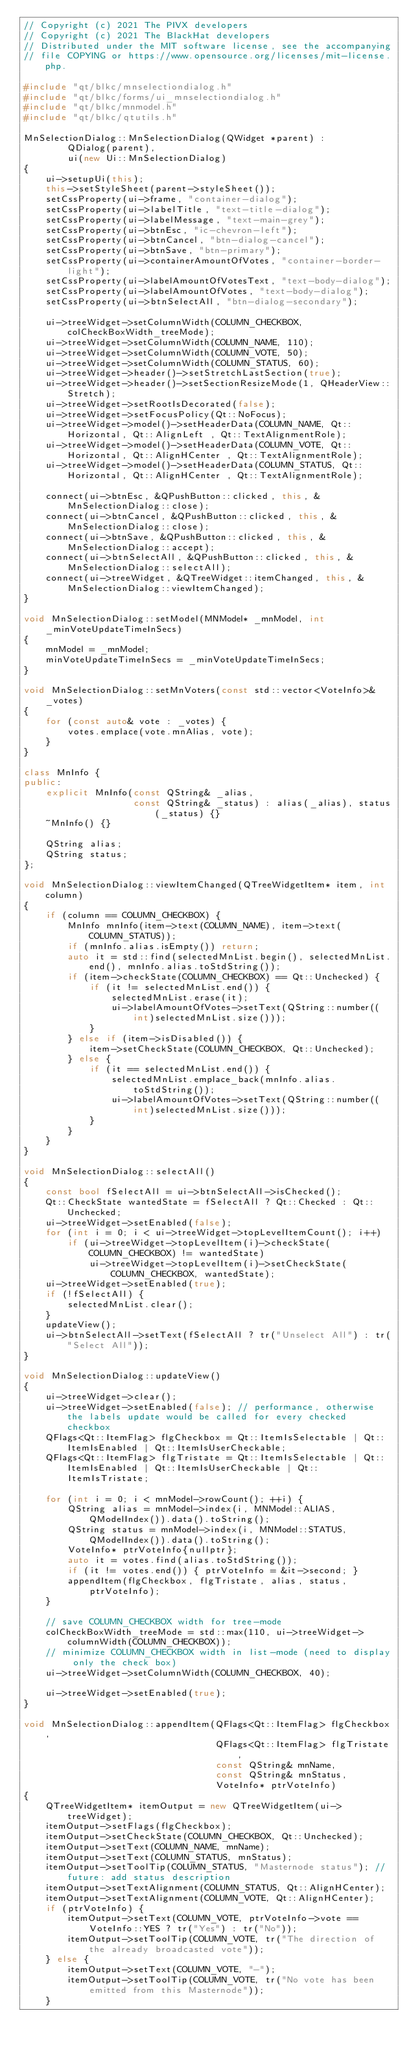Convert code to text. <code><loc_0><loc_0><loc_500><loc_500><_C++_>// Copyright (c) 2021 The PIVX developers
// Copyright (c) 2021 The BlackHat developers
// Distributed under the MIT software license, see the accompanying
// file COPYING or https://www.opensource.org/licenses/mit-license.php.

#include "qt/blkc/mnselectiondialog.h"
#include "qt/blkc/forms/ui_mnselectiondialog.h"
#include "qt/blkc/mnmodel.h"
#include "qt/blkc/qtutils.h"

MnSelectionDialog::MnSelectionDialog(QWidget *parent) :
        QDialog(parent),
        ui(new Ui::MnSelectionDialog)
{
    ui->setupUi(this);
    this->setStyleSheet(parent->styleSheet());
    setCssProperty(ui->frame, "container-dialog");
    setCssProperty(ui->labelTitle, "text-title-dialog");
    setCssProperty(ui->labelMessage, "text-main-grey");
    setCssProperty(ui->btnEsc, "ic-chevron-left");
    setCssProperty(ui->btnCancel, "btn-dialog-cancel");
    setCssProperty(ui->btnSave, "btn-primary");
    setCssProperty(ui->containerAmountOfVotes, "container-border-light");
    setCssProperty(ui->labelAmountOfVotesText, "text-body-dialog");
    setCssProperty(ui->labelAmountOfVotes, "text-body-dialog");
    setCssProperty(ui->btnSelectAll, "btn-dialog-secondary");

    ui->treeWidget->setColumnWidth(COLUMN_CHECKBOX, colCheckBoxWidth_treeMode);
    ui->treeWidget->setColumnWidth(COLUMN_NAME, 110);
    ui->treeWidget->setColumnWidth(COLUMN_VOTE, 50);
    ui->treeWidget->setColumnWidth(COLUMN_STATUS, 60);
    ui->treeWidget->header()->setStretchLastSection(true);
    ui->treeWidget->header()->setSectionResizeMode(1, QHeaderView::Stretch);
    ui->treeWidget->setRootIsDecorated(false);
    ui->treeWidget->setFocusPolicy(Qt::NoFocus);
    ui->treeWidget->model()->setHeaderData(COLUMN_NAME, Qt::Horizontal, Qt::AlignLeft , Qt::TextAlignmentRole);
    ui->treeWidget->model()->setHeaderData(COLUMN_VOTE, Qt::Horizontal, Qt::AlignHCenter , Qt::TextAlignmentRole);
    ui->treeWidget->model()->setHeaderData(COLUMN_STATUS, Qt::Horizontal, Qt::AlignHCenter , Qt::TextAlignmentRole);

    connect(ui->btnEsc, &QPushButton::clicked, this, &MnSelectionDialog::close);
    connect(ui->btnCancel, &QPushButton::clicked, this, &MnSelectionDialog::close);
    connect(ui->btnSave, &QPushButton::clicked, this, &MnSelectionDialog::accept);
    connect(ui->btnSelectAll, &QPushButton::clicked, this, &MnSelectionDialog::selectAll);
    connect(ui->treeWidget, &QTreeWidget::itemChanged, this, &MnSelectionDialog::viewItemChanged);
}

void MnSelectionDialog::setModel(MNModel* _mnModel, int _minVoteUpdateTimeInSecs)
{
    mnModel = _mnModel;
    minVoteUpdateTimeInSecs = _minVoteUpdateTimeInSecs;
}

void MnSelectionDialog::setMnVoters(const std::vector<VoteInfo>& _votes)
{
    for (const auto& vote : _votes) {
        votes.emplace(vote.mnAlias, vote);
    }
}

class MnInfo {
public:
    explicit MnInfo(const QString& _alias,
                    const QString& _status) : alias(_alias), status(_status) {}
    ~MnInfo() {}

    QString alias;
    QString status;
};

void MnSelectionDialog::viewItemChanged(QTreeWidgetItem* item, int column)
{
    if (column == COLUMN_CHECKBOX) {
        MnInfo mnInfo(item->text(COLUMN_NAME), item->text(COLUMN_STATUS));
        if (mnInfo.alias.isEmpty()) return;
        auto it = std::find(selectedMnList.begin(), selectedMnList.end(), mnInfo.alias.toStdString());
        if (item->checkState(COLUMN_CHECKBOX) == Qt::Unchecked) {
            if (it != selectedMnList.end()) {
                selectedMnList.erase(it);
                ui->labelAmountOfVotes->setText(QString::number((int)selectedMnList.size()));
            }
        } else if (item->isDisabled()) {
            item->setCheckState(COLUMN_CHECKBOX, Qt::Unchecked);
        } else {
            if (it == selectedMnList.end()) {
                selectedMnList.emplace_back(mnInfo.alias.toStdString());
                ui->labelAmountOfVotes->setText(QString::number((int)selectedMnList.size()));
            }
        }
    }
}

void MnSelectionDialog::selectAll()
{
    const bool fSelectAll = ui->btnSelectAll->isChecked();
    Qt::CheckState wantedState = fSelectAll ? Qt::Checked : Qt::Unchecked;
    ui->treeWidget->setEnabled(false);
    for (int i = 0; i < ui->treeWidget->topLevelItemCount(); i++)
        if (ui->treeWidget->topLevelItem(i)->checkState(COLUMN_CHECKBOX) != wantedState)
            ui->treeWidget->topLevelItem(i)->setCheckState(COLUMN_CHECKBOX, wantedState);
    ui->treeWidget->setEnabled(true);
    if (!fSelectAll) {
        selectedMnList.clear();
    }
    updateView();
    ui->btnSelectAll->setText(fSelectAll ? tr("Unselect All") : tr("Select All"));
}

void MnSelectionDialog::updateView()
{
    ui->treeWidget->clear();
    ui->treeWidget->setEnabled(false); // performance, otherwise the labels update would be called for every checked checkbox
    QFlags<Qt::ItemFlag> flgCheckbox = Qt::ItemIsSelectable | Qt::ItemIsEnabled | Qt::ItemIsUserCheckable;
    QFlags<Qt::ItemFlag> flgTristate = Qt::ItemIsSelectable | Qt::ItemIsEnabled | Qt::ItemIsUserCheckable | Qt::ItemIsTristate;

    for (int i = 0; i < mnModel->rowCount(); ++i) {
        QString alias = mnModel->index(i, MNModel::ALIAS, QModelIndex()).data().toString();
        QString status = mnModel->index(i, MNModel::STATUS, QModelIndex()).data().toString();
        VoteInfo* ptrVoteInfo{nullptr};
        auto it = votes.find(alias.toStdString());
        if (it != votes.end()) { ptrVoteInfo = &it->second; }
        appendItem(flgCheckbox, flgTristate, alias, status, ptrVoteInfo);
    }

    // save COLUMN_CHECKBOX width for tree-mode
    colCheckBoxWidth_treeMode = std::max(110, ui->treeWidget->columnWidth(COLUMN_CHECKBOX));
    // minimize COLUMN_CHECKBOX width in list-mode (need to display only the check box)
    ui->treeWidget->setColumnWidth(COLUMN_CHECKBOX, 40);

    ui->treeWidget->setEnabled(true);
}

void MnSelectionDialog::appendItem(QFlags<Qt::ItemFlag> flgCheckbox,
                                   QFlags<Qt::ItemFlag> flgTristate,
                                   const QString& mnName,
                                   const QString& mnStatus,
                                   VoteInfo* ptrVoteInfo)
{
    QTreeWidgetItem* itemOutput = new QTreeWidgetItem(ui->treeWidget);
    itemOutput->setFlags(flgCheckbox);
    itemOutput->setCheckState(COLUMN_CHECKBOX, Qt::Unchecked);
    itemOutput->setText(COLUMN_NAME, mnName);
    itemOutput->setText(COLUMN_STATUS, mnStatus);
    itemOutput->setToolTip(COLUMN_STATUS, "Masternode status"); // future: add status description
    itemOutput->setTextAlignment(COLUMN_STATUS, Qt::AlignHCenter);
    itemOutput->setTextAlignment(COLUMN_VOTE, Qt::AlignHCenter);
    if (ptrVoteInfo) {
        itemOutput->setText(COLUMN_VOTE, ptrVoteInfo->vote == VoteInfo::YES ? tr("Yes") : tr("No"));
        itemOutput->setToolTip(COLUMN_VOTE, tr("The direction of the already broadcasted vote"));
    } else {
        itemOutput->setText(COLUMN_VOTE, "-");
        itemOutput->setToolTip(COLUMN_VOTE, tr("No vote has been emitted from this Masternode"));
    }
</code> 